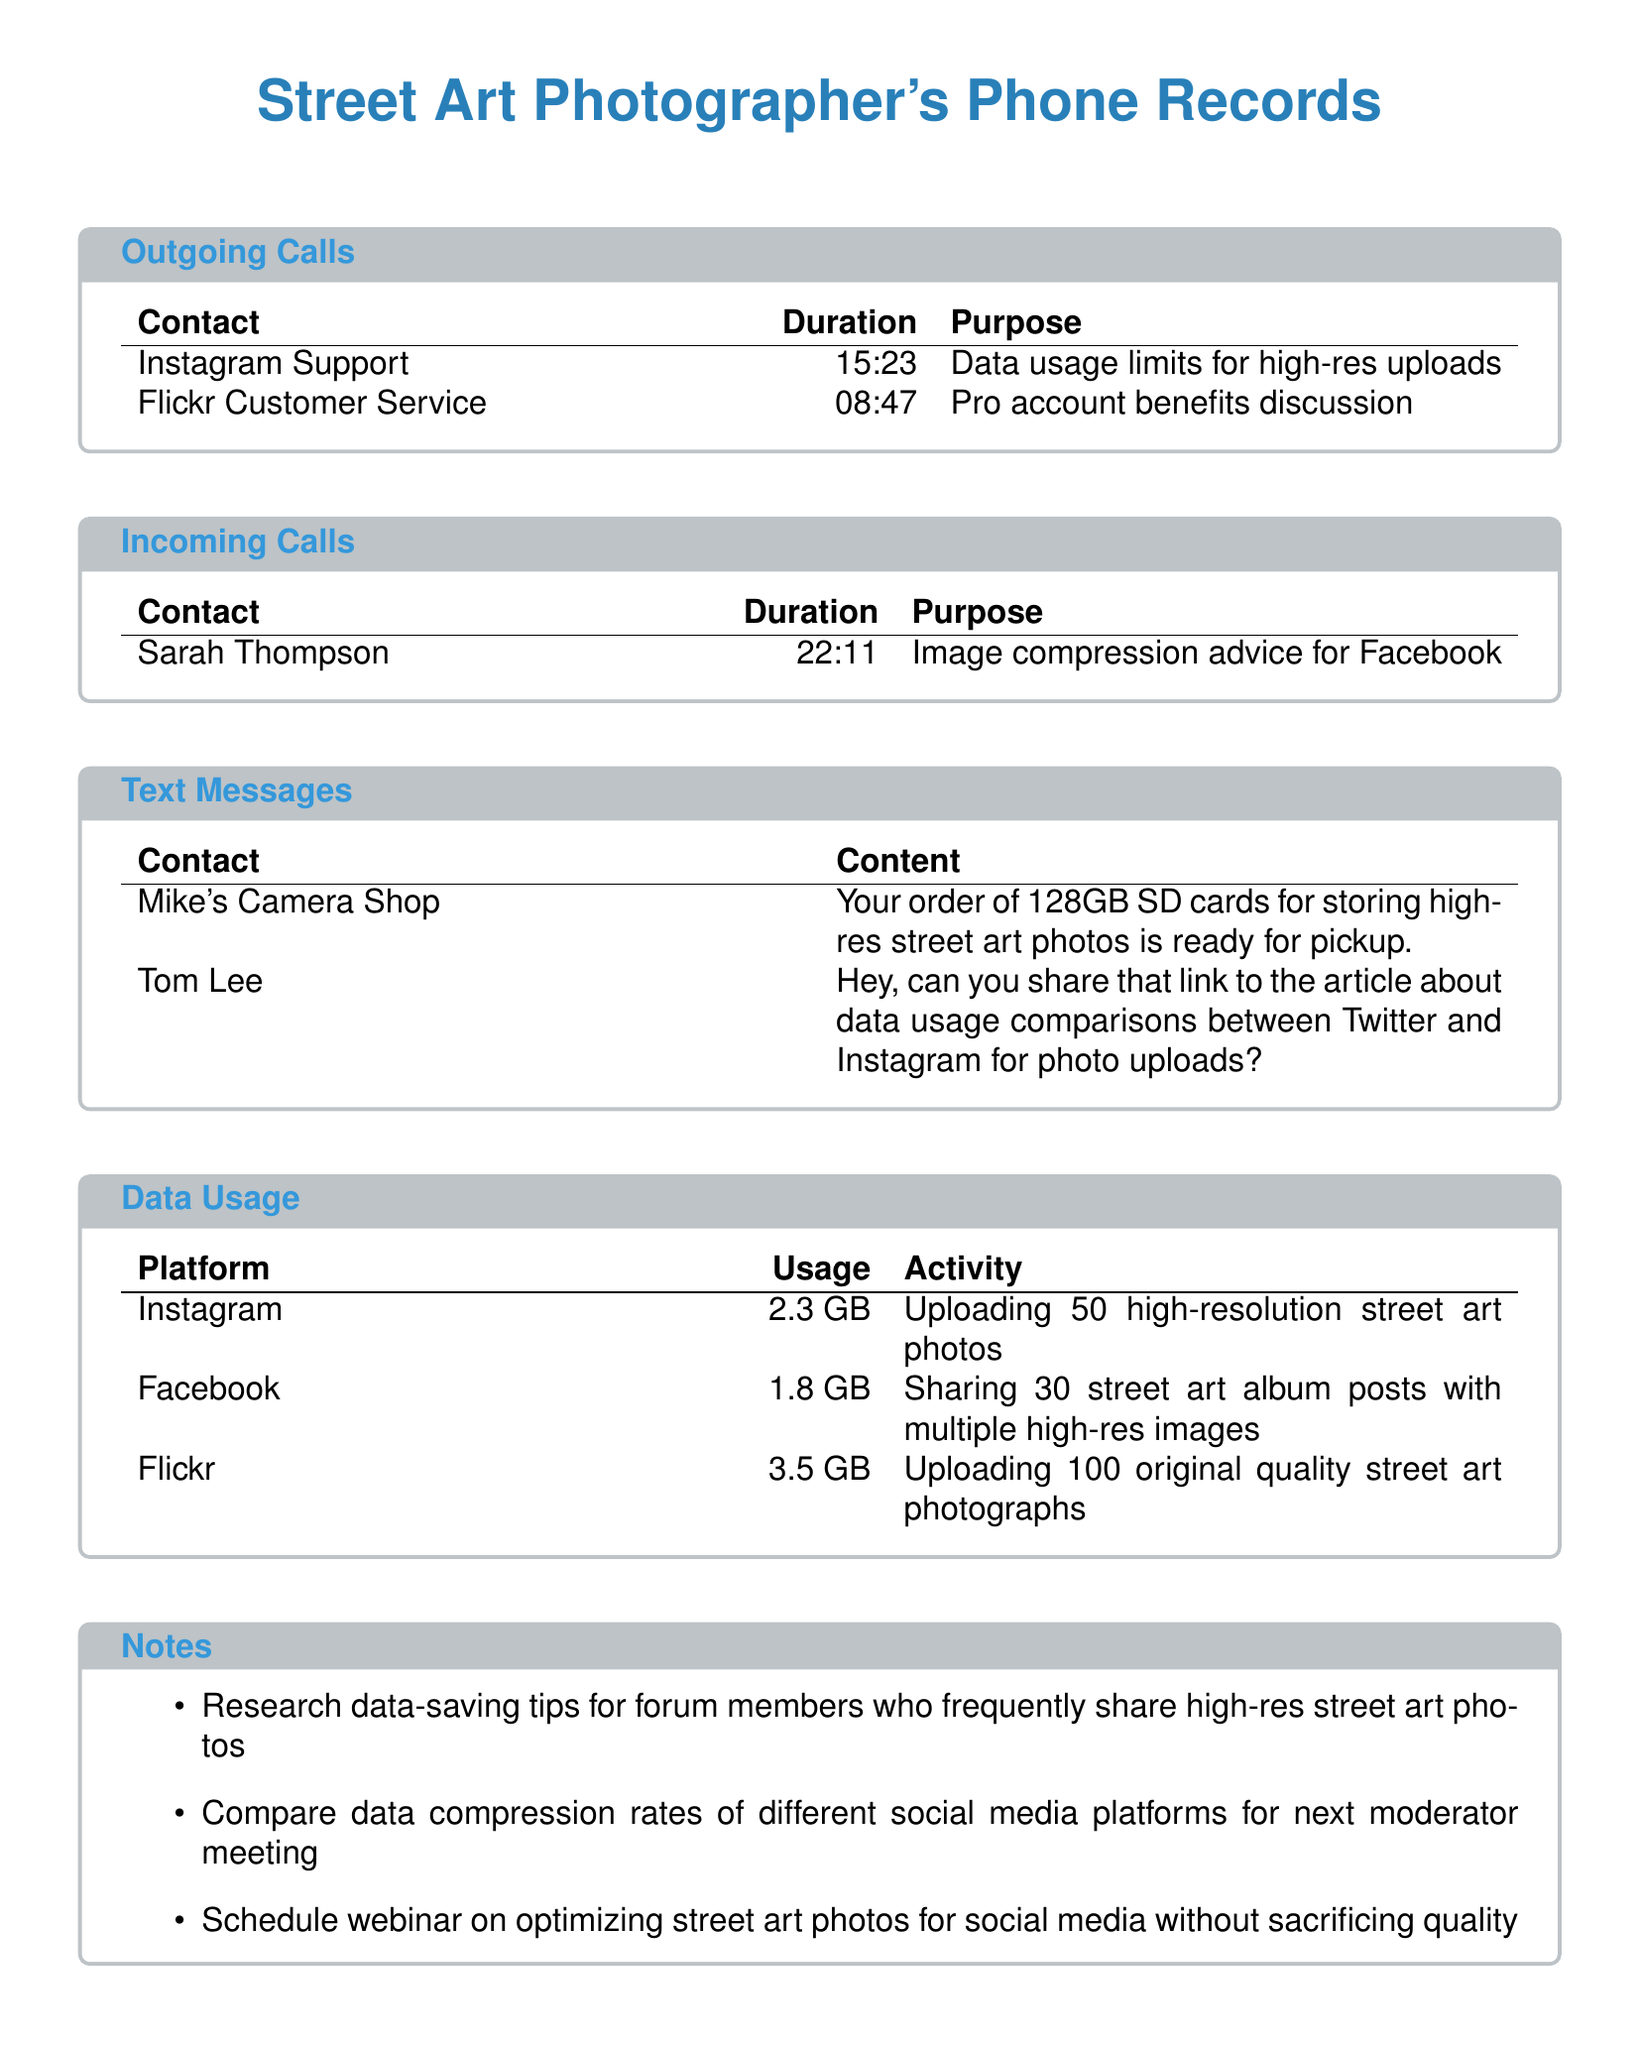What is the duration of the call with Instagram Support? The duration of the call is provided in the telephone records, specifically for Instagram Support.
Answer: 15:23 How much data was used for uploading street art photos on Flickr? The data usage is listed for each platform in the data usage section, showing Flickr's usage.
Answer: 3.5 GB What advice did Sarah Thompson provide? The purpose of the incoming call with Sarah Thompson was to discuss image compression advice specifically for Facebook.
Answer: Image compression advice for Facebook Who is the contact for the order of 128GB SD cards? The text message information mentions a contact related to a specific order.
Answer: Mike's Camera Shop How many high-resolution photos were uploaded to Instagram? The details under data usage mention the number of photos uploaded to Instagram.
Answer: 50 high-resolution street art photos What is the total data usage for all platforms? The total can be calculated by summing the individual data usages listed for Instagram, Facebook, and Flickr.
Answer: 7.6 GB Which customer service was contacted to discuss pro account benefits? The contact for discussing pro account benefits is explicitly mentioned in the outgoing calls section.
Answer: Flickr Customer Service What is one of the notes listed in the document? A note in the notes section includes various research or meeting ideas related to data usage in photography.
Answer: Research data-saving tips for forum members who frequently share high-res street art photos How long was the incoming call with Sarah Thompson? The duration of the incoming call is specified in the phone records detailing the contacting party.
Answer: 22:11 